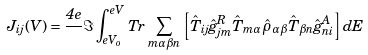<formula> <loc_0><loc_0><loc_500><loc_500>J _ { i j } ( V ) = \frac { 4 e } { } \Im \int _ { e V _ { o } } ^ { e V } \, T r \, \sum _ { m \alpha \beta n } \left [ \hat { T } _ { i j } \hat { g } _ { j m } ^ { R } \hat { T } _ { m \alpha } \hat { \rho } _ { \alpha \beta } \hat { T } _ { \beta n } \hat { g } _ { n i } ^ { A } \right ] d E</formula> 